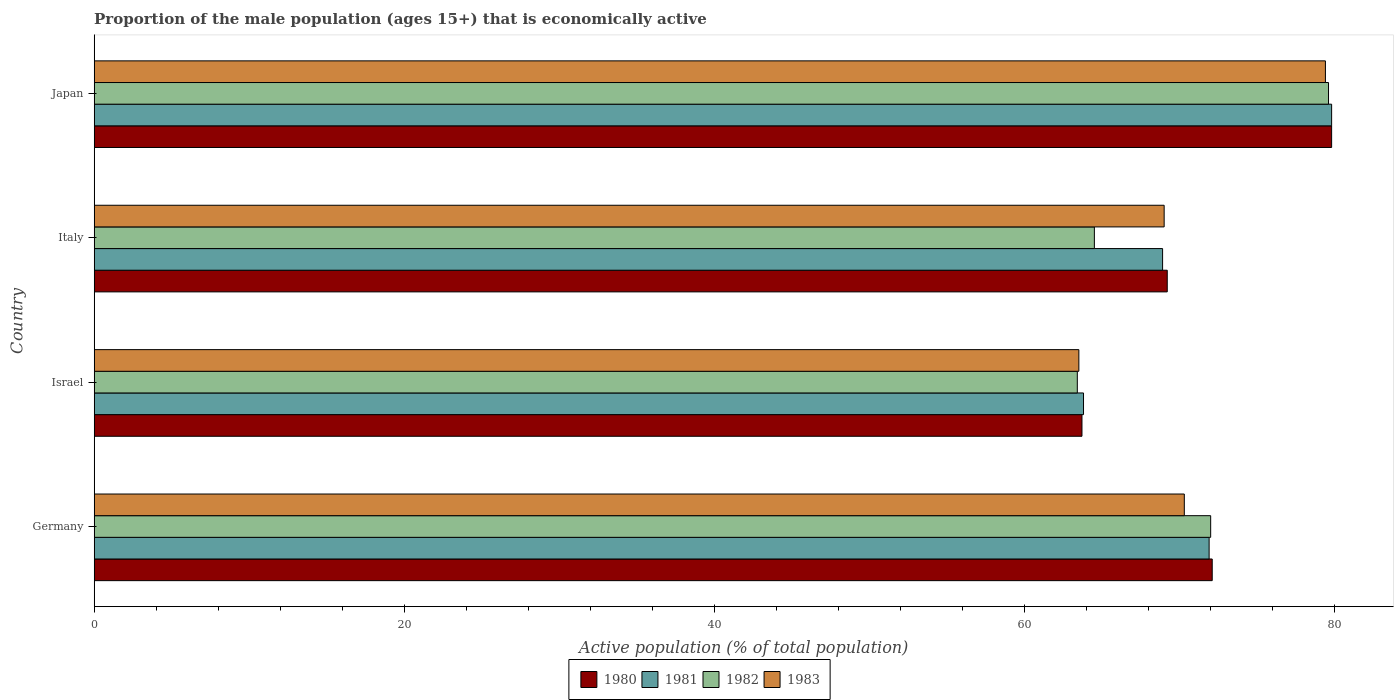How many groups of bars are there?
Ensure brevity in your answer.  4. Are the number of bars on each tick of the Y-axis equal?
Offer a very short reply. Yes. How many bars are there on the 4th tick from the bottom?
Your answer should be very brief. 4. In how many cases, is the number of bars for a given country not equal to the number of legend labels?
Keep it short and to the point. 0. What is the proportion of the male population that is economically active in 1982 in Italy?
Make the answer very short. 64.5. Across all countries, what is the maximum proportion of the male population that is economically active in 1982?
Provide a short and direct response. 79.6. Across all countries, what is the minimum proportion of the male population that is economically active in 1982?
Keep it short and to the point. 63.4. In which country was the proportion of the male population that is economically active in 1980 maximum?
Make the answer very short. Japan. In which country was the proportion of the male population that is economically active in 1982 minimum?
Ensure brevity in your answer.  Israel. What is the total proportion of the male population that is economically active in 1980 in the graph?
Offer a terse response. 284.8. What is the difference between the proportion of the male population that is economically active in 1983 in Israel and that in Japan?
Keep it short and to the point. -15.9. What is the difference between the proportion of the male population that is economically active in 1980 in Italy and the proportion of the male population that is economically active in 1981 in Israel?
Keep it short and to the point. 5.4. What is the average proportion of the male population that is economically active in 1982 per country?
Your answer should be very brief. 69.87. What is the difference between the proportion of the male population that is economically active in 1981 and proportion of the male population that is economically active in 1983 in Italy?
Offer a very short reply. -0.1. What is the ratio of the proportion of the male population that is economically active in 1982 in Italy to that in Japan?
Ensure brevity in your answer.  0.81. Is the proportion of the male population that is economically active in 1981 in Germany less than that in Israel?
Give a very brief answer. No. Is the difference between the proportion of the male population that is economically active in 1981 in Italy and Japan greater than the difference between the proportion of the male population that is economically active in 1983 in Italy and Japan?
Your response must be concise. No. What is the difference between the highest and the second highest proportion of the male population that is economically active in 1981?
Your answer should be compact. 7.9. What is the difference between the highest and the lowest proportion of the male population that is economically active in 1981?
Your response must be concise. 16. In how many countries, is the proportion of the male population that is economically active in 1982 greater than the average proportion of the male population that is economically active in 1982 taken over all countries?
Offer a terse response. 2. Is the sum of the proportion of the male population that is economically active in 1983 in Germany and Italy greater than the maximum proportion of the male population that is economically active in 1980 across all countries?
Give a very brief answer. Yes. What is the difference between two consecutive major ticks on the X-axis?
Offer a very short reply. 20. Are the values on the major ticks of X-axis written in scientific E-notation?
Offer a very short reply. No. Does the graph contain any zero values?
Your answer should be very brief. No. What is the title of the graph?
Your response must be concise. Proportion of the male population (ages 15+) that is economically active. Does "1984" appear as one of the legend labels in the graph?
Make the answer very short. No. What is the label or title of the X-axis?
Give a very brief answer. Active population (% of total population). What is the label or title of the Y-axis?
Keep it short and to the point. Country. What is the Active population (% of total population) in 1980 in Germany?
Give a very brief answer. 72.1. What is the Active population (% of total population) of 1981 in Germany?
Provide a succinct answer. 71.9. What is the Active population (% of total population) in 1982 in Germany?
Make the answer very short. 72. What is the Active population (% of total population) of 1983 in Germany?
Your answer should be very brief. 70.3. What is the Active population (% of total population) in 1980 in Israel?
Ensure brevity in your answer.  63.7. What is the Active population (% of total population) of 1981 in Israel?
Provide a short and direct response. 63.8. What is the Active population (% of total population) of 1982 in Israel?
Offer a terse response. 63.4. What is the Active population (% of total population) in 1983 in Israel?
Offer a very short reply. 63.5. What is the Active population (% of total population) in 1980 in Italy?
Make the answer very short. 69.2. What is the Active population (% of total population) of 1981 in Italy?
Offer a very short reply. 68.9. What is the Active population (% of total population) of 1982 in Italy?
Provide a succinct answer. 64.5. What is the Active population (% of total population) in 1983 in Italy?
Your answer should be very brief. 69. What is the Active population (% of total population) of 1980 in Japan?
Provide a short and direct response. 79.8. What is the Active population (% of total population) in 1981 in Japan?
Your answer should be compact. 79.8. What is the Active population (% of total population) of 1982 in Japan?
Your answer should be very brief. 79.6. What is the Active population (% of total population) in 1983 in Japan?
Provide a succinct answer. 79.4. Across all countries, what is the maximum Active population (% of total population) in 1980?
Your answer should be very brief. 79.8. Across all countries, what is the maximum Active population (% of total population) in 1981?
Keep it short and to the point. 79.8. Across all countries, what is the maximum Active population (% of total population) in 1982?
Your answer should be compact. 79.6. Across all countries, what is the maximum Active population (% of total population) in 1983?
Make the answer very short. 79.4. Across all countries, what is the minimum Active population (% of total population) in 1980?
Provide a succinct answer. 63.7. Across all countries, what is the minimum Active population (% of total population) of 1981?
Your answer should be very brief. 63.8. Across all countries, what is the minimum Active population (% of total population) in 1982?
Keep it short and to the point. 63.4. Across all countries, what is the minimum Active population (% of total population) in 1983?
Your response must be concise. 63.5. What is the total Active population (% of total population) of 1980 in the graph?
Provide a short and direct response. 284.8. What is the total Active population (% of total population) in 1981 in the graph?
Make the answer very short. 284.4. What is the total Active population (% of total population) of 1982 in the graph?
Provide a short and direct response. 279.5. What is the total Active population (% of total population) of 1983 in the graph?
Offer a terse response. 282.2. What is the difference between the Active population (% of total population) in 1980 in Germany and that in Israel?
Offer a very short reply. 8.4. What is the difference between the Active population (% of total population) of 1981 in Germany and that in Israel?
Ensure brevity in your answer.  8.1. What is the difference between the Active population (% of total population) in 1982 in Germany and that in Israel?
Your answer should be very brief. 8.6. What is the difference between the Active population (% of total population) of 1983 in Germany and that in Israel?
Your response must be concise. 6.8. What is the difference between the Active population (% of total population) of 1981 in Germany and that in Italy?
Provide a short and direct response. 3. What is the difference between the Active population (% of total population) of 1982 in Germany and that in Italy?
Provide a succinct answer. 7.5. What is the difference between the Active population (% of total population) of 1983 in Germany and that in Italy?
Make the answer very short. 1.3. What is the difference between the Active population (% of total population) in 1981 in Germany and that in Japan?
Offer a terse response. -7.9. What is the difference between the Active population (% of total population) of 1982 in Germany and that in Japan?
Provide a succinct answer. -7.6. What is the difference between the Active population (% of total population) in 1981 in Israel and that in Italy?
Make the answer very short. -5.1. What is the difference between the Active population (% of total population) of 1980 in Israel and that in Japan?
Your response must be concise. -16.1. What is the difference between the Active population (% of total population) in 1982 in Israel and that in Japan?
Your answer should be compact. -16.2. What is the difference between the Active population (% of total population) in 1983 in Israel and that in Japan?
Ensure brevity in your answer.  -15.9. What is the difference between the Active population (% of total population) in 1982 in Italy and that in Japan?
Make the answer very short. -15.1. What is the difference between the Active population (% of total population) in 1983 in Italy and that in Japan?
Your answer should be very brief. -10.4. What is the difference between the Active population (% of total population) of 1980 in Germany and the Active population (% of total population) of 1983 in Israel?
Give a very brief answer. 8.6. What is the difference between the Active population (% of total population) of 1981 in Germany and the Active population (% of total population) of 1983 in Israel?
Ensure brevity in your answer.  8.4. What is the difference between the Active population (% of total population) of 1980 in Germany and the Active population (% of total population) of 1983 in Italy?
Make the answer very short. 3.1. What is the difference between the Active population (% of total population) in 1981 in Germany and the Active population (% of total population) in 1982 in Italy?
Give a very brief answer. 7.4. What is the difference between the Active population (% of total population) in 1982 in Germany and the Active population (% of total population) in 1983 in Italy?
Your response must be concise. 3. What is the difference between the Active population (% of total population) in 1980 in Germany and the Active population (% of total population) in 1982 in Japan?
Provide a short and direct response. -7.5. What is the difference between the Active population (% of total population) of 1981 in Germany and the Active population (% of total population) of 1982 in Japan?
Make the answer very short. -7.7. What is the difference between the Active population (% of total population) of 1981 in Germany and the Active population (% of total population) of 1983 in Japan?
Make the answer very short. -7.5. What is the difference between the Active population (% of total population) in 1982 in Germany and the Active population (% of total population) in 1983 in Japan?
Provide a succinct answer. -7.4. What is the difference between the Active population (% of total population) in 1980 in Israel and the Active population (% of total population) in 1983 in Italy?
Offer a very short reply. -5.3. What is the difference between the Active population (% of total population) of 1981 in Israel and the Active population (% of total population) of 1982 in Italy?
Offer a very short reply. -0.7. What is the difference between the Active population (% of total population) in 1982 in Israel and the Active population (% of total population) in 1983 in Italy?
Keep it short and to the point. -5.6. What is the difference between the Active population (% of total population) of 1980 in Israel and the Active population (% of total population) of 1981 in Japan?
Ensure brevity in your answer.  -16.1. What is the difference between the Active population (% of total population) in 1980 in Israel and the Active population (% of total population) in 1982 in Japan?
Your answer should be compact. -15.9. What is the difference between the Active population (% of total population) in 1980 in Israel and the Active population (% of total population) in 1983 in Japan?
Give a very brief answer. -15.7. What is the difference between the Active population (% of total population) in 1981 in Israel and the Active population (% of total population) in 1982 in Japan?
Provide a short and direct response. -15.8. What is the difference between the Active population (% of total population) in 1981 in Israel and the Active population (% of total population) in 1983 in Japan?
Offer a very short reply. -15.6. What is the difference between the Active population (% of total population) in 1982 in Israel and the Active population (% of total population) in 1983 in Japan?
Make the answer very short. -16. What is the difference between the Active population (% of total population) of 1980 in Italy and the Active population (% of total population) of 1982 in Japan?
Make the answer very short. -10.4. What is the difference between the Active population (% of total population) of 1980 in Italy and the Active population (% of total population) of 1983 in Japan?
Offer a very short reply. -10.2. What is the difference between the Active population (% of total population) of 1981 in Italy and the Active population (% of total population) of 1983 in Japan?
Your response must be concise. -10.5. What is the difference between the Active population (% of total population) of 1982 in Italy and the Active population (% of total population) of 1983 in Japan?
Your answer should be very brief. -14.9. What is the average Active population (% of total population) of 1980 per country?
Offer a terse response. 71.2. What is the average Active population (% of total population) in 1981 per country?
Provide a succinct answer. 71.1. What is the average Active population (% of total population) of 1982 per country?
Your answer should be compact. 69.88. What is the average Active population (% of total population) of 1983 per country?
Give a very brief answer. 70.55. What is the difference between the Active population (% of total population) in 1980 and Active population (% of total population) in 1981 in Germany?
Provide a short and direct response. 0.2. What is the difference between the Active population (% of total population) of 1980 and Active population (% of total population) of 1982 in Germany?
Offer a very short reply. 0.1. What is the difference between the Active population (% of total population) in 1980 and Active population (% of total population) in 1982 in Israel?
Offer a very short reply. 0.3. What is the difference between the Active population (% of total population) in 1980 and Active population (% of total population) in 1983 in Israel?
Provide a succinct answer. 0.2. What is the difference between the Active population (% of total population) in 1981 and Active population (% of total population) in 1983 in Israel?
Your answer should be compact. 0.3. What is the difference between the Active population (% of total population) of 1980 and Active population (% of total population) of 1981 in Italy?
Offer a very short reply. 0.3. What is the difference between the Active population (% of total population) of 1981 and Active population (% of total population) of 1982 in Italy?
Offer a very short reply. 4.4. What is the difference between the Active population (% of total population) in 1980 and Active population (% of total population) in 1981 in Japan?
Offer a very short reply. 0. What is the difference between the Active population (% of total population) in 1980 and Active population (% of total population) in 1982 in Japan?
Your answer should be compact. 0.2. What is the difference between the Active population (% of total population) of 1982 and Active population (% of total population) of 1983 in Japan?
Your response must be concise. 0.2. What is the ratio of the Active population (% of total population) of 1980 in Germany to that in Israel?
Keep it short and to the point. 1.13. What is the ratio of the Active population (% of total population) in 1981 in Germany to that in Israel?
Provide a short and direct response. 1.13. What is the ratio of the Active population (% of total population) in 1982 in Germany to that in Israel?
Give a very brief answer. 1.14. What is the ratio of the Active population (% of total population) in 1983 in Germany to that in Israel?
Provide a short and direct response. 1.11. What is the ratio of the Active population (% of total population) in 1980 in Germany to that in Italy?
Your response must be concise. 1.04. What is the ratio of the Active population (% of total population) of 1981 in Germany to that in Italy?
Offer a very short reply. 1.04. What is the ratio of the Active population (% of total population) in 1982 in Germany to that in Italy?
Your answer should be compact. 1.12. What is the ratio of the Active population (% of total population) in 1983 in Germany to that in Italy?
Your response must be concise. 1.02. What is the ratio of the Active population (% of total population) in 1980 in Germany to that in Japan?
Offer a very short reply. 0.9. What is the ratio of the Active population (% of total population) in 1981 in Germany to that in Japan?
Offer a terse response. 0.9. What is the ratio of the Active population (% of total population) in 1982 in Germany to that in Japan?
Make the answer very short. 0.9. What is the ratio of the Active population (% of total population) in 1983 in Germany to that in Japan?
Your answer should be compact. 0.89. What is the ratio of the Active population (% of total population) in 1980 in Israel to that in Italy?
Keep it short and to the point. 0.92. What is the ratio of the Active population (% of total population) in 1981 in Israel to that in Italy?
Offer a very short reply. 0.93. What is the ratio of the Active population (% of total population) of 1982 in Israel to that in Italy?
Ensure brevity in your answer.  0.98. What is the ratio of the Active population (% of total population) in 1983 in Israel to that in Italy?
Your answer should be very brief. 0.92. What is the ratio of the Active population (% of total population) in 1980 in Israel to that in Japan?
Offer a terse response. 0.8. What is the ratio of the Active population (% of total population) of 1981 in Israel to that in Japan?
Provide a short and direct response. 0.8. What is the ratio of the Active population (% of total population) of 1982 in Israel to that in Japan?
Ensure brevity in your answer.  0.8. What is the ratio of the Active population (% of total population) of 1983 in Israel to that in Japan?
Your response must be concise. 0.8. What is the ratio of the Active population (% of total population) in 1980 in Italy to that in Japan?
Offer a terse response. 0.87. What is the ratio of the Active population (% of total population) of 1981 in Italy to that in Japan?
Provide a succinct answer. 0.86. What is the ratio of the Active population (% of total population) of 1982 in Italy to that in Japan?
Offer a very short reply. 0.81. What is the ratio of the Active population (% of total population) in 1983 in Italy to that in Japan?
Your answer should be very brief. 0.87. What is the difference between the highest and the second highest Active population (% of total population) of 1980?
Ensure brevity in your answer.  7.7. What is the difference between the highest and the lowest Active population (% of total population) of 1980?
Provide a succinct answer. 16.1. 